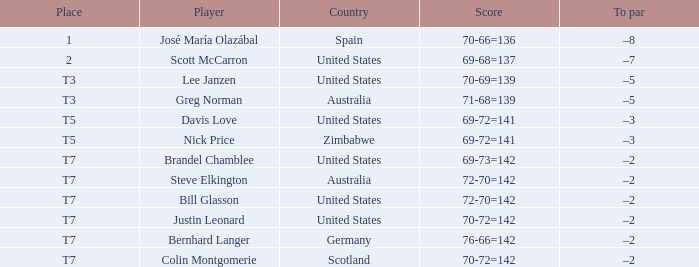Name the Player who has a Place of t7 in Country of united states? Brandel Chamblee, Bill Glasson, Justin Leonard. 